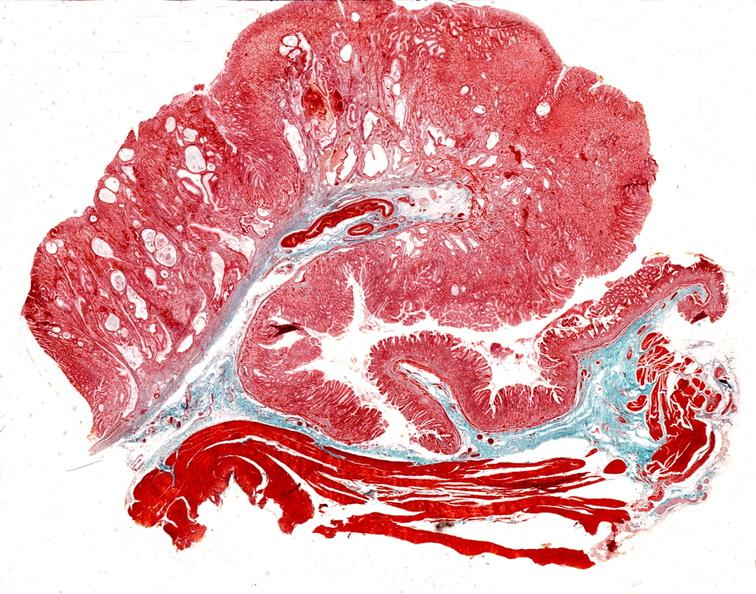where is this from?
Answer the question using a single word or phrase. Gastrointestinal system 